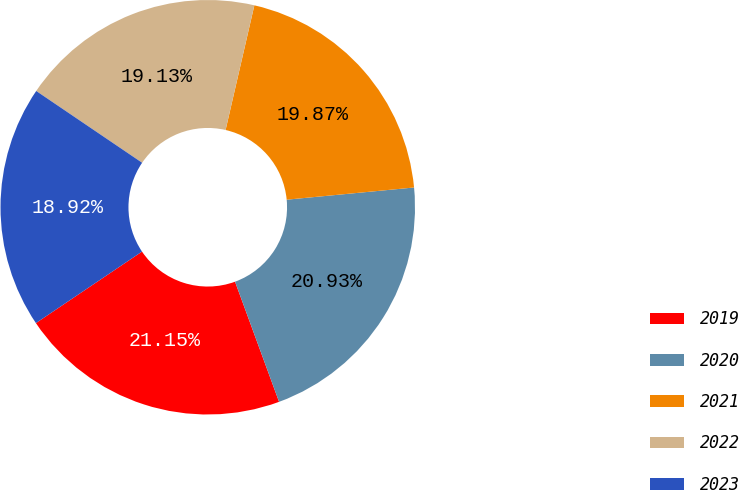<chart> <loc_0><loc_0><loc_500><loc_500><pie_chart><fcel>2019<fcel>2020<fcel>2021<fcel>2022<fcel>2023<nl><fcel>21.15%<fcel>20.93%<fcel>19.87%<fcel>19.13%<fcel>18.92%<nl></chart> 